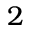Convert formula to latex. <formula><loc_0><loc_0><loc_500><loc_500>2</formula> 